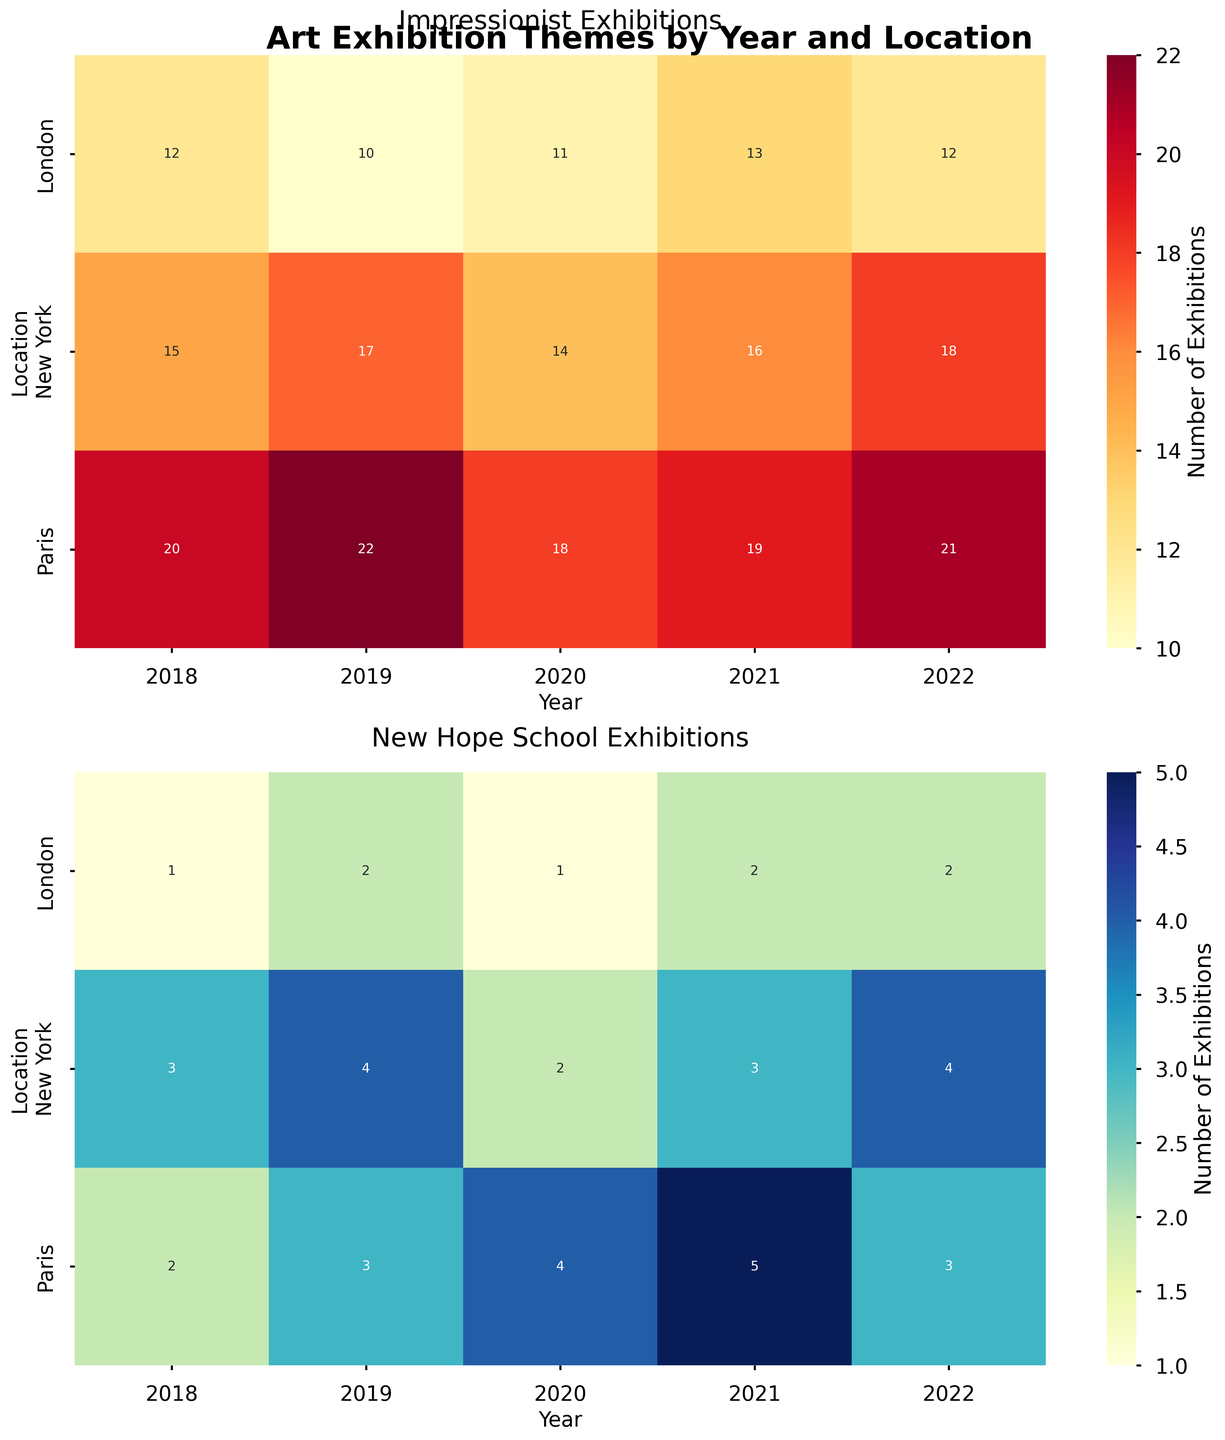What's the overall title of the figure? The overall title is displayed at the top center of the figure.
Answer: Art Exhibition Themes by Year and Location How many exhibitions were held in Paris in 2021 for the New Hope School? Locate the row corresponding to Paris and the column corresponding to 2021 in the second heatmap. The value is annotated on the heatmap.
Answer: 5 Which year saw the highest number of Impressionist exhibitions in New York? In the first heatmap, find the cell with the highest value in the New York row. The year corresponding to this column is the answer.
Answer: 2022 What is the difference in the number of Impressionist exhibitions between 2018 and 2020 in London? In the first heatmap, locate the values for London in 2018 and 2020. Calculate the difference by subtracting the 2020 value from the 2018 value.
Answer: 1 Compare the total number of New Hope School exhibitions in Paris from 2018 to 2022 to those in New York in the same years. Sum the values in the New Hope School heatmap for Paris from 2018 to 2022 and compare them to the summed values for New York.
Answer: Paris: 17, New York: 16 Which location had the most consistent number of Impressionist exhibitions over the years? Observe the first heatmap and identify the location where values are least variable across years.
Answer: New York What is the increase in the number of New Hope School exhibitions in Paris from 2020 to 2021? In the second heatmap, find the difference in the number of exhibitions in Paris between 2021 and 2020.
Answer: 1 How does the peak year for New Hope School exhibitions in London compare to the peak year for Impressionist exhibitions in the same city? Find the highest value in the London row for both heatmaps and compare the corresponding years.
Answer: London (New Hope School): 2019, London (Impressionist): 2018 Which city had the highest number of Impressionist exhibitions in 2018? Locate the 2018 column in the Impressionist heatmap and find the highest value across locations.
Answer: Paris What is the average number of New Hope School exhibitions held in London from 2018 to 2022? Add the values for London from 2018 to 2022 in the New Hope School heatmap and divide by the number of years (5).
Answer: 1.6 